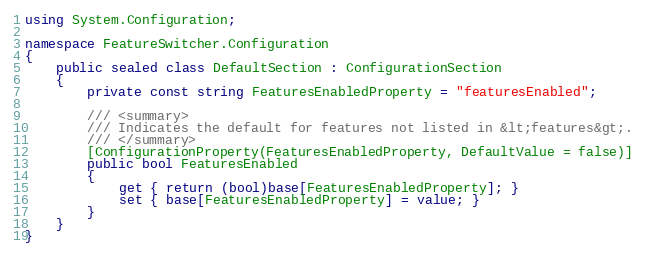<code> <loc_0><loc_0><loc_500><loc_500><_C#_>using System.Configuration;

namespace FeatureSwitcher.Configuration
{
    public sealed class DefaultSection : ConfigurationSection
    {
        private const string FeaturesEnabledProperty = "featuresEnabled";

        /// <summary>
        /// Indicates the default for features not listed in &lt;features&gt;.
        /// </summary>
        [ConfigurationProperty(FeaturesEnabledProperty, DefaultValue = false)]
        public bool FeaturesEnabled
        {
            get { return (bool)base[FeaturesEnabledProperty]; }
            set { base[FeaturesEnabledProperty] = value; }
        }
    }
}</code> 